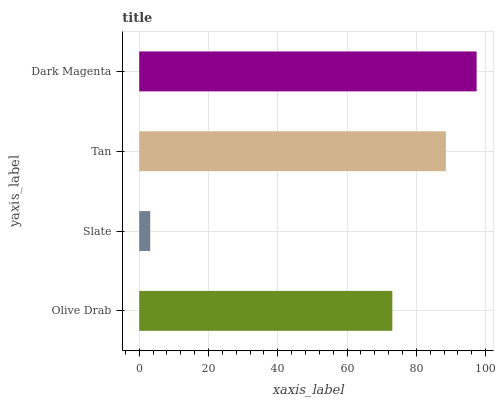Is Slate the minimum?
Answer yes or no. Yes. Is Dark Magenta the maximum?
Answer yes or no. Yes. Is Tan the minimum?
Answer yes or no. No. Is Tan the maximum?
Answer yes or no. No. Is Tan greater than Slate?
Answer yes or no. Yes. Is Slate less than Tan?
Answer yes or no. Yes. Is Slate greater than Tan?
Answer yes or no. No. Is Tan less than Slate?
Answer yes or no. No. Is Tan the high median?
Answer yes or no. Yes. Is Olive Drab the low median?
Answer yes or no. Yes. Is Slate the high median?
Answer yes or no. No. Is Tan the low median?
Answer yes or no. No. 